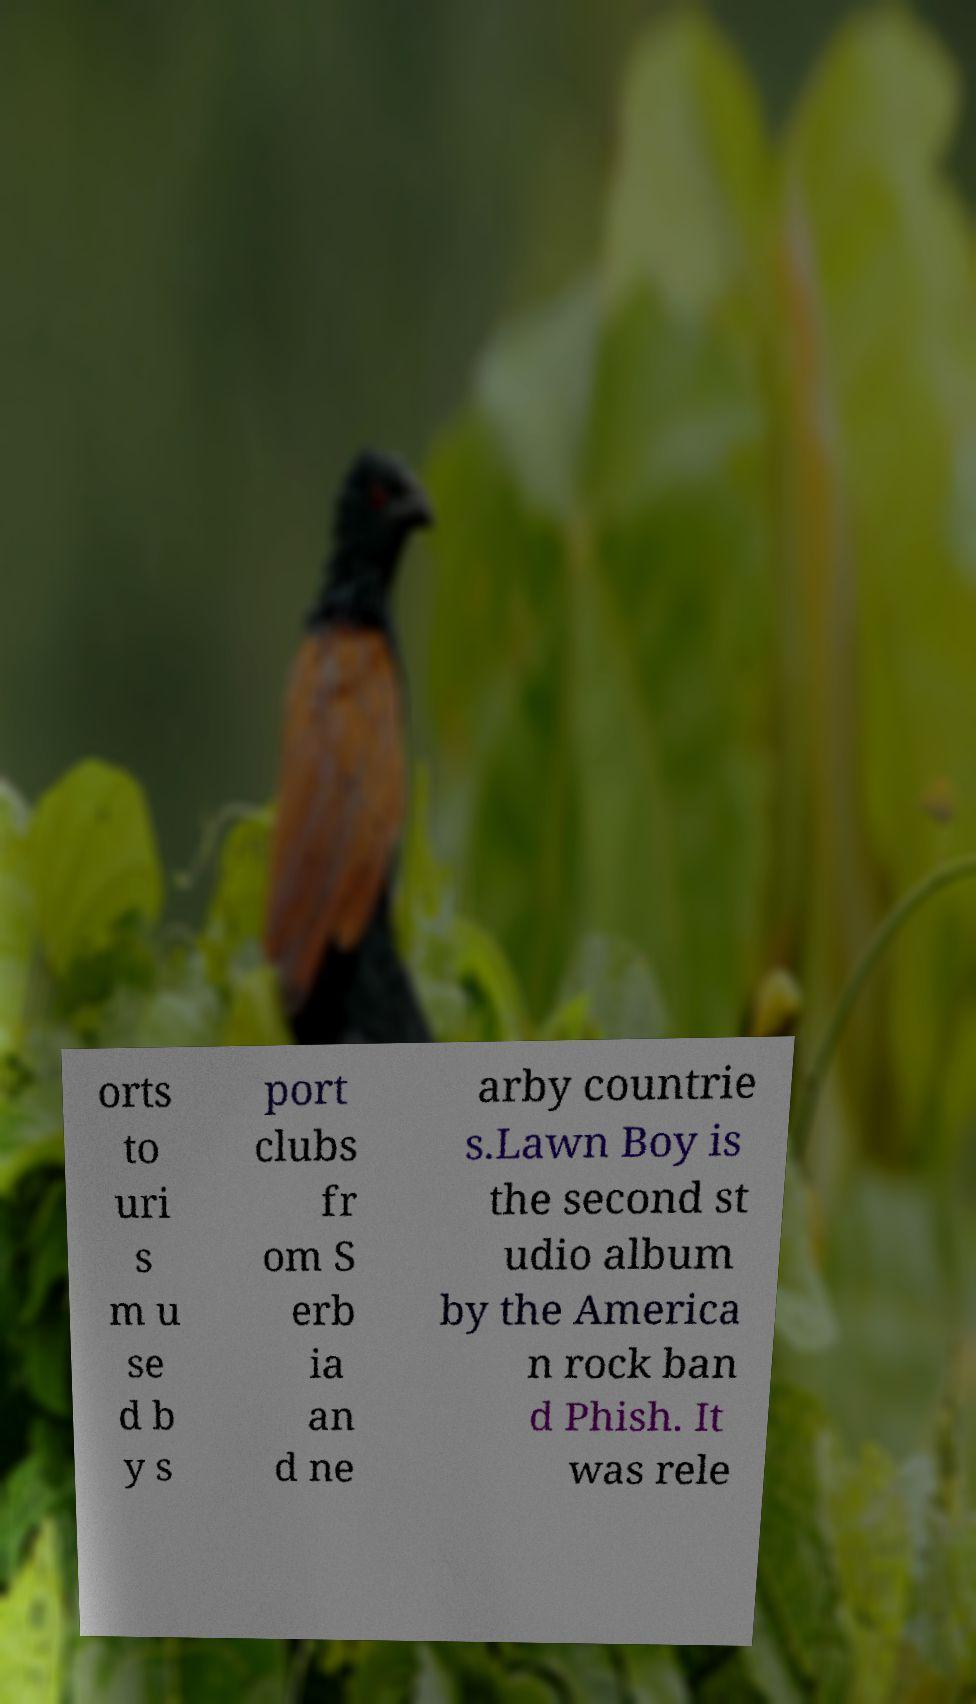For documentation purposes, I need the text within this image transcribed. Could you provide that? orts to uri s m u se d b y s port clubs fr om S erb ia an d ne arby countrie s.Lawn Boy is the second st udio album by the America n rock ban d Phish. It was rele 